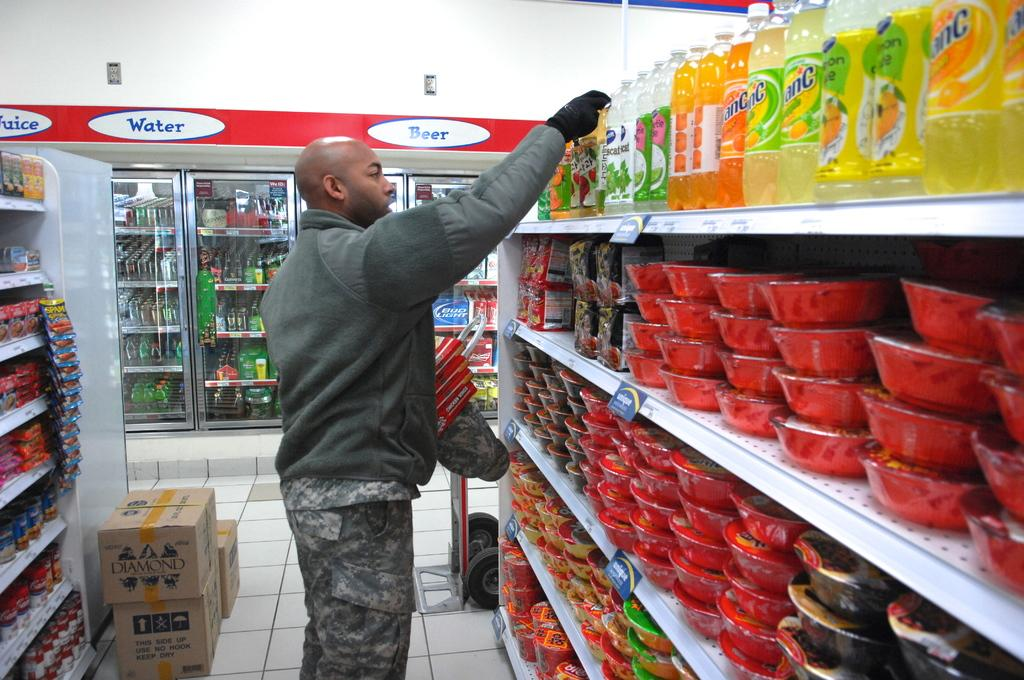<image>
Relay a brief, clear account of the picture shown. A man stocks a store's shelves in front of water, juice, and beer coolers. 